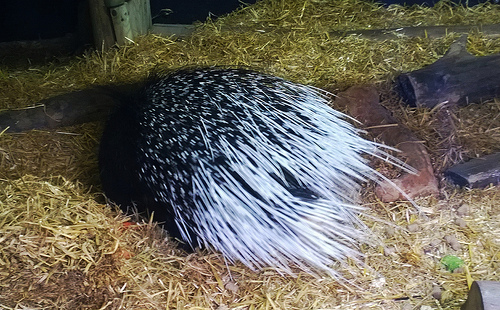<image>
Can you confirm if the quill is next to the hay? No. The quill is not positioned next to the hay. They are located in different areas of the scene. 